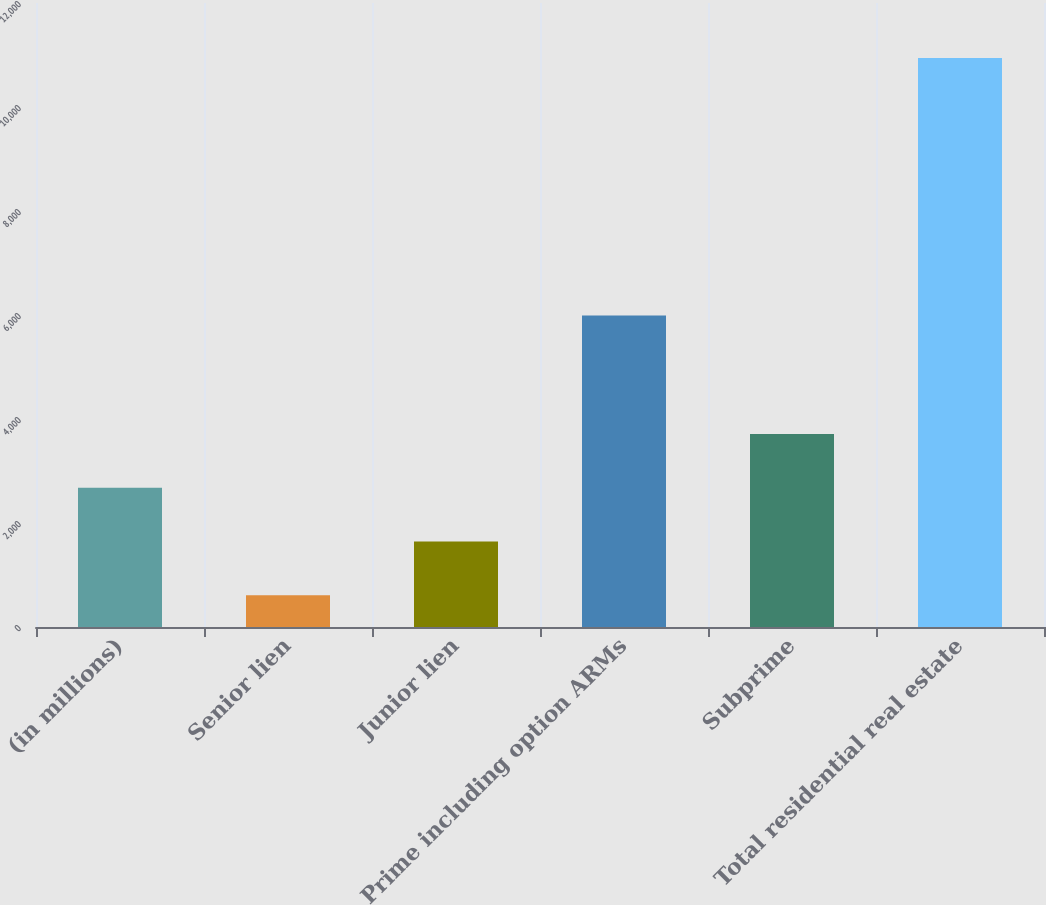<chart> <loc_0><loc_0><loc_500><loc_500><bar_chart><fcel>(in millions)<fcel>Senior lien<fcel>Junior lien<fcel>Prime including option ARMs<fcel>Subprime<fcel>Total residential real estate<nl><fcel>2676.2<fcel>610<fcel>1643.1<fcel>5989<fcel>3709.3<fcel>10941<nl></chart> 